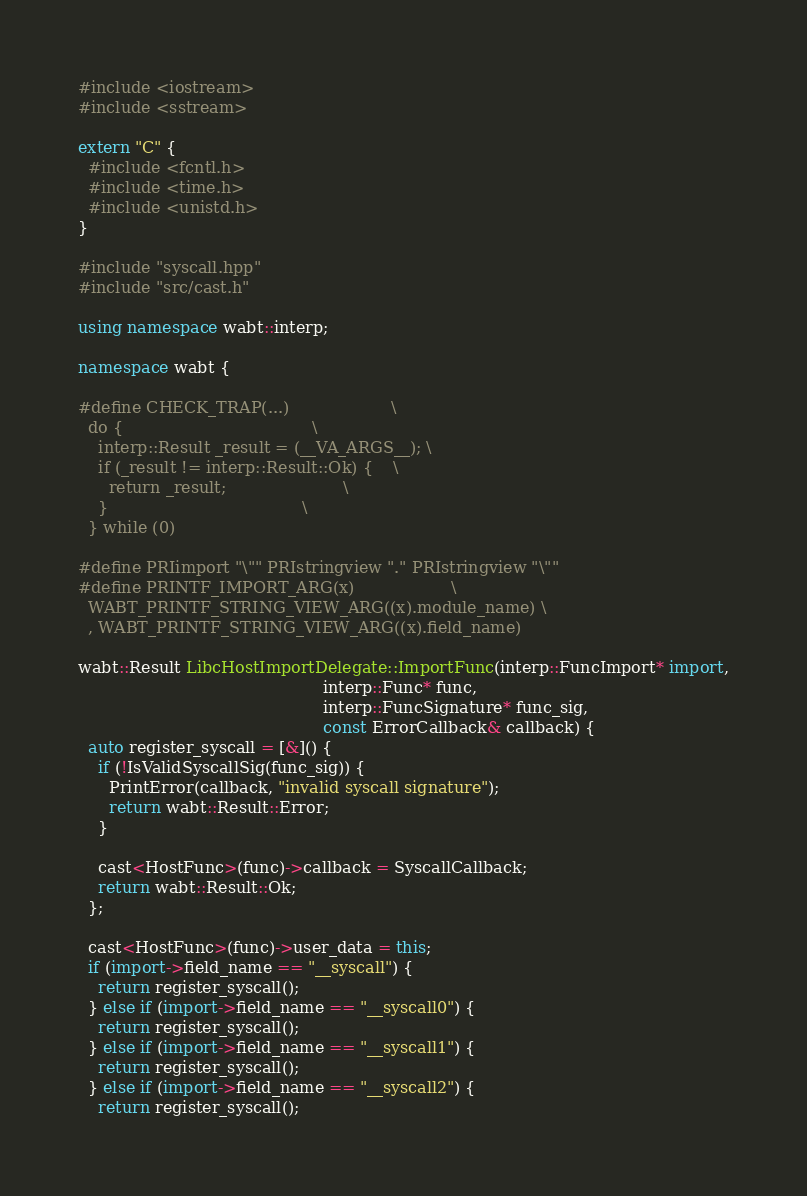<code> <loc_0><loc_0><loc_500><loc_500><_C++_>#include <iostream>
#include <sstream>

extern "C" {
  #include <fcntl.h>
  #include <time.h>
  #include <unistd.h>
}

#include "syscall.hpp"
#include "src/cast.h"

using namespace wabt::interp;

namespace wabt {

#define CHECK_TRAP(...)                    \
  do {                                     \
    interp::Result _result = (__VA_ARGS__); \
    if (_result != interp::Result::Ok) {    \
      return _result;                       \
    }                                      \
  } while (0)

#define PRIimport "\"" PRIstringview "." PRIstringview "\""
#define PRINTF_IMPORT_ARG(x)                   \
  WABT_PRINTF_STRING_VIEW_ARG((x).module_name) \
  , WABT_PRINTF_STRING_VIEW_ARG((x).field_name)

wabt::Result LibcHostImportDelegate::ImportFunc(interp::FuncImport* import,
                                                interp::Func* func,
                                                interp::FuncSignature* func_sig,
                                                const ErrorCallback& callback) {
  auto register_syscall = [&]() {
    if (!IsValidSyscallSig(func_sig)) {
      PrintError(callback, "invalid syscall signature");
      return wabt::Result::Error;
    }

    cast<HostFunc>(func)->callback = SyscallCallback;
    return wabt::Result::Ok;
  };

  cast<HostFunc>(func)->user_data = this;
  if (import->field_name == "__syscall") {
    return register_syscall();
  } else if (import->field_name == "__syscall0") {
    return register_syscall();
  } else if (import->field_name == "__syscall1") {
    return register_syscall();
  } else if (import->field_name == "__syscall2") {
    return register_syscall();</code> 